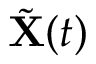<formula> <loc_0><loc_0><loc_500><loc_500>\tilde { X } ( t )</formula> 